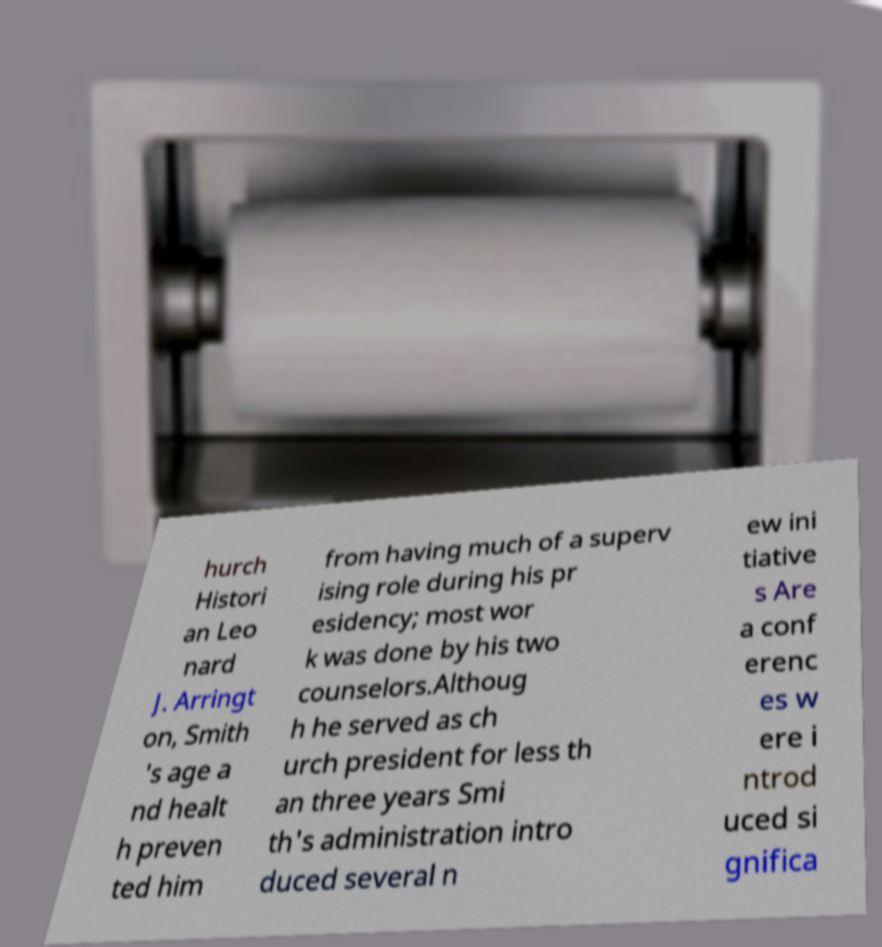Could you extract and type out the text from this image? hurch Histori an Leo nard J. Arringt on, Smith 's age a nd healt h preven ted him from having much of a superv ising role during his pr esidency; most wor k was done by his two counselors.Althoug h he served as ch urch president for less th an three years Smi th's administration intro duced several n ew ini tiative s Are a conf erenc es w ere i ntrod uced si gnifica 